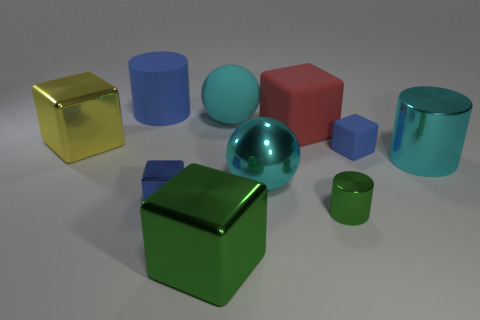Can you tell me the colors of the objects besides the big yellow one? Aside from the yellow cube, there are several objects of different colors: a blue cylinder, a red cube, a teal sphere, a green cube, and a cyan cylinder.  Which object appears to be the smallest? The smallest object seems to be the green cuboid. It has the least volume in comparison to the other shapes present. 